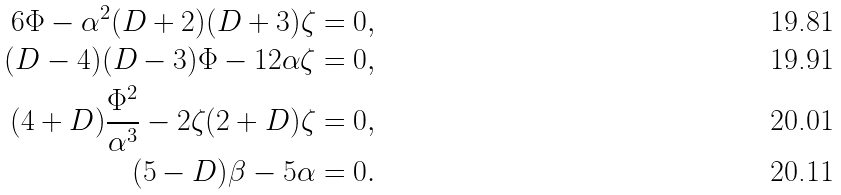Convert formula to latex. <formula><loc_0><loc_0><loc_500><loc_500>6 \Phi - \alpha ^ { 2 } ( D + 2 ) ( D + 3 ) \zeta & = 0 , \\ ( D - 4 ) ( D - 3 ) \Phi - 1 2 \alpha \zeta & = 0 , \\ ( 4 + D ) \frac { \Phi ^ { 2 } } { \alpha ^ { 3 } } - 2 \zeta ( 2 + D ) \zeta & = 0 , \\ ( 5 - D ) \beta - 5 \alpha & = 0 .</formula> 